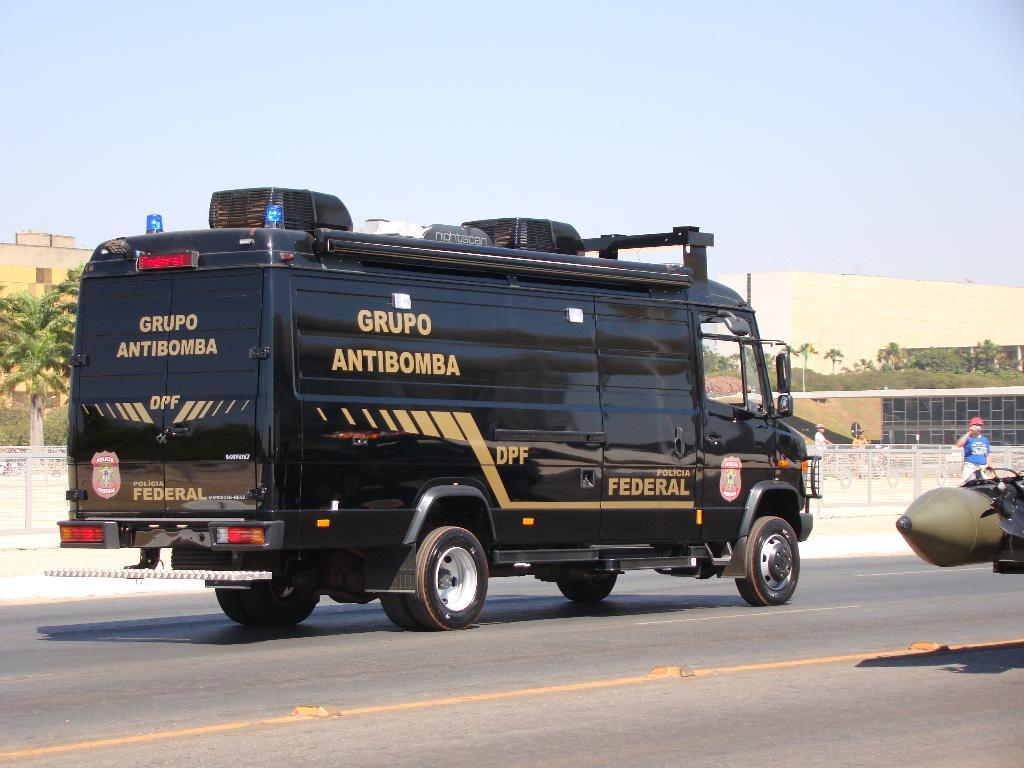<image>
Render a clear and concise summary of the photo. A black truck that says "Grupo Antibomba" drives on a street. 